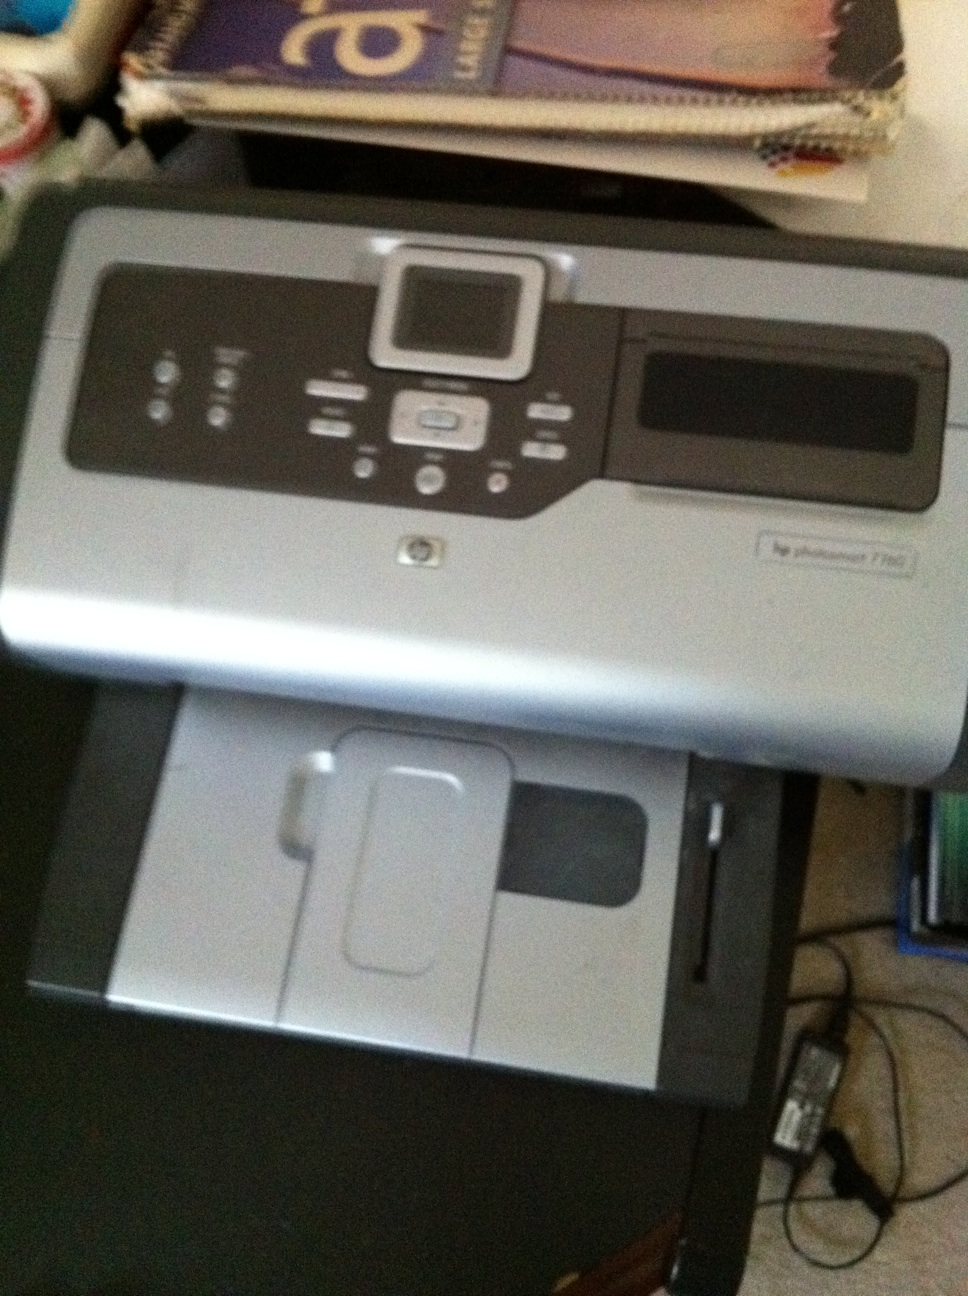What type of paper does this printer support? The HP Photosmart 7280 supports a wide variety of paper types including plain paper, photo paper, brochure paper, and envelopes. The paper tray can accommodate various sizes such as letter, legal, 4 x 6 inches, and 5 x 7 inches. 